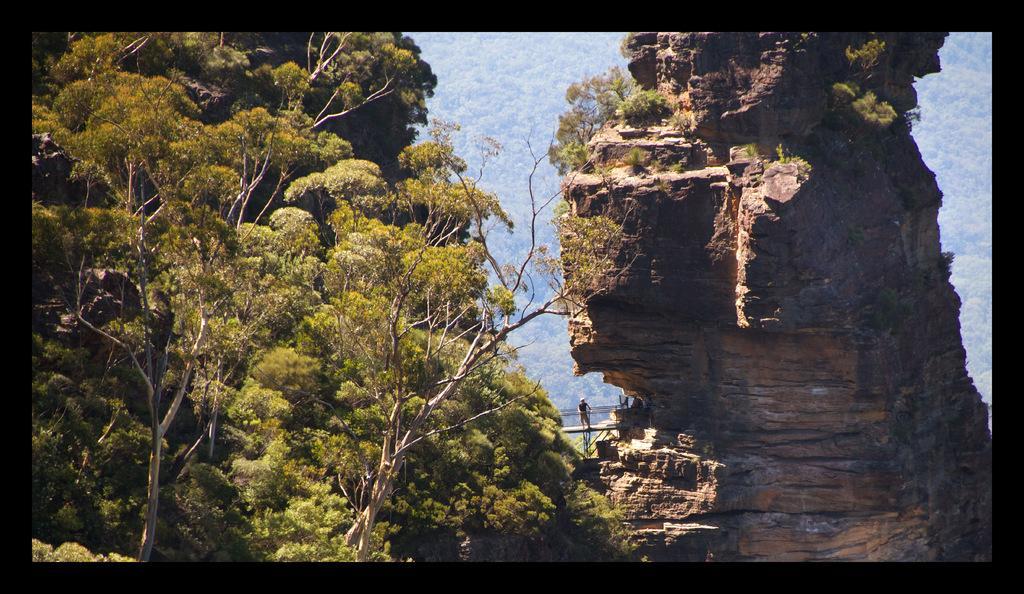In one or two sentences, can you explain what this image depicts? In this image I can see on the left side there are trees, in the middle a person is standing. On the right side there is the hill. 